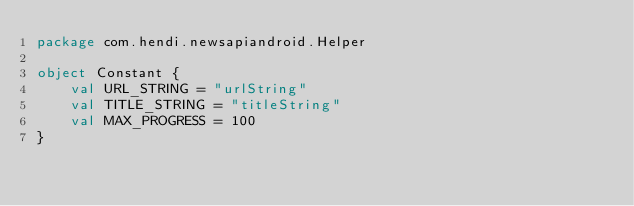Convert code to text. <code><loc_0><loc_0><loc_500><loc_500><_Kotlin_>package com.hendi.newsapiandroid.Helper

object Constant {
    val URL_STRING = "urlString"
    val TITLE_STRING = "titleString"
    val MAX_PROGRESS = 100
}</code> 